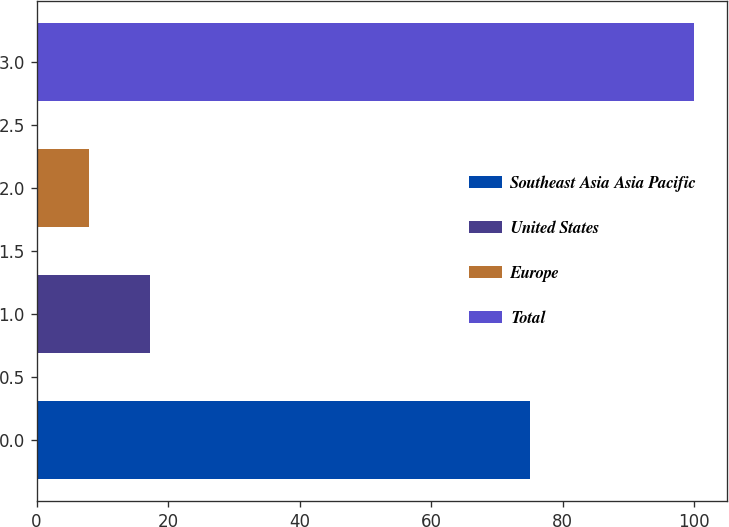<chart> <loc_0><loc_0><loc_500><loc_500><bar_chart><fcel>Southeast Asia Asia Pacific<fcel>United States<fcel>Europe<fcel>Total<nl><fcel>75<fcel>17.2<fcel>8<fcel>100<nl></chart> 